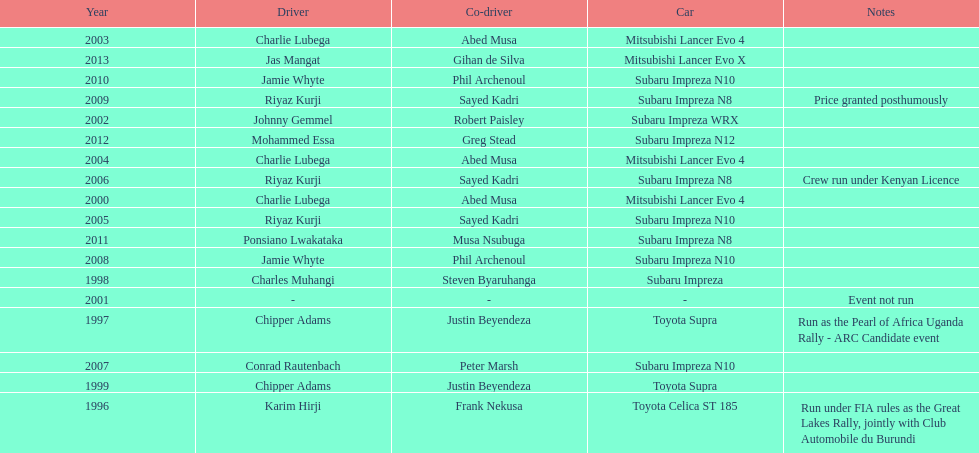Do chipper adams and justin beyendeza have more than 3 wins? No. 